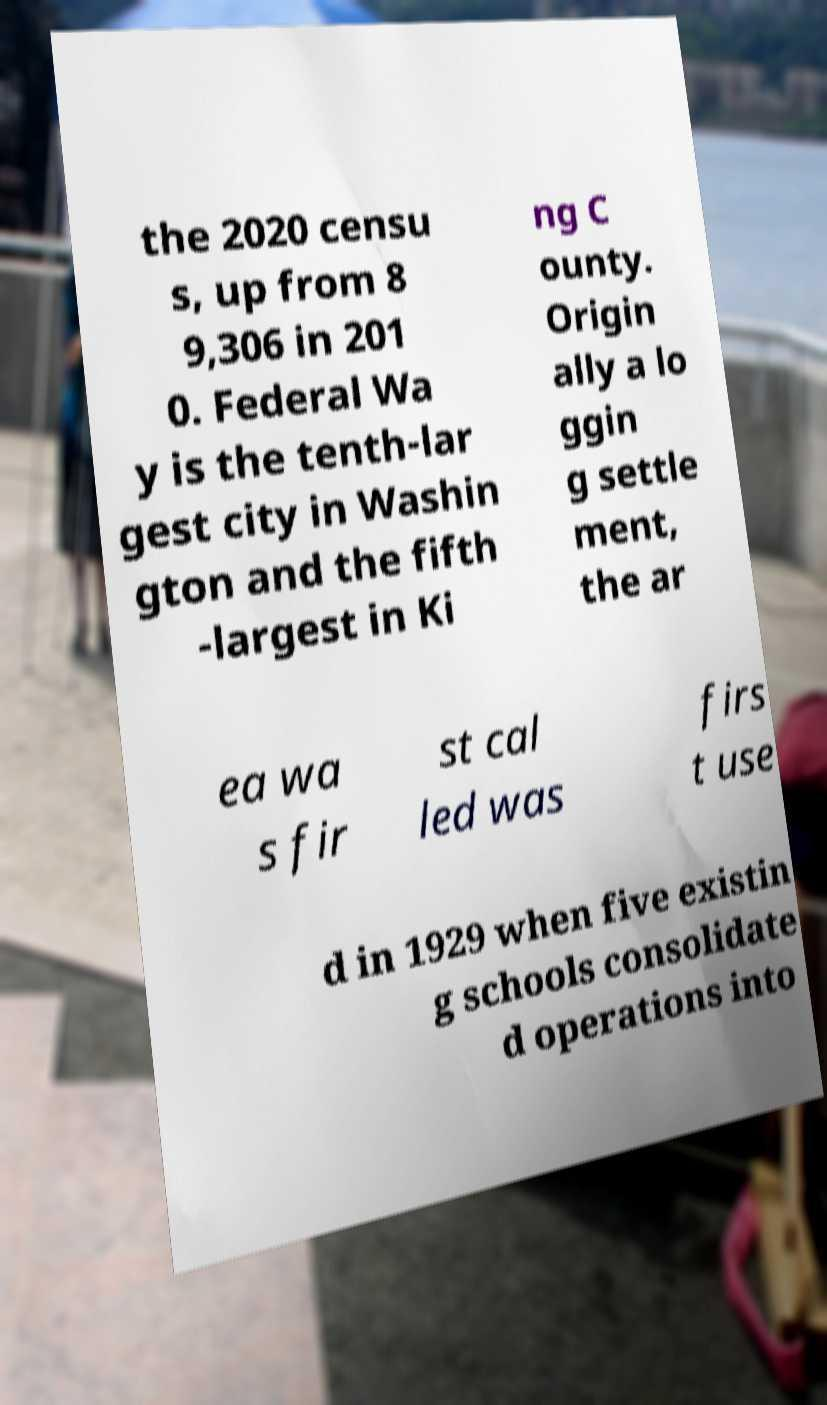Please read and relay the text visible in this image. What does it say? the 2020 censu s, up from 8 9,306 in 201 0. Federal Wa y is the tenth-lar gest city in Washin gton and the fifth -largest in Ki ng C ounty. Origin ally a lo ggin g settle ment, the ar ea wa s fir st cal led was firs t use d in 1929 when five existin g schools consolidate d operations into 